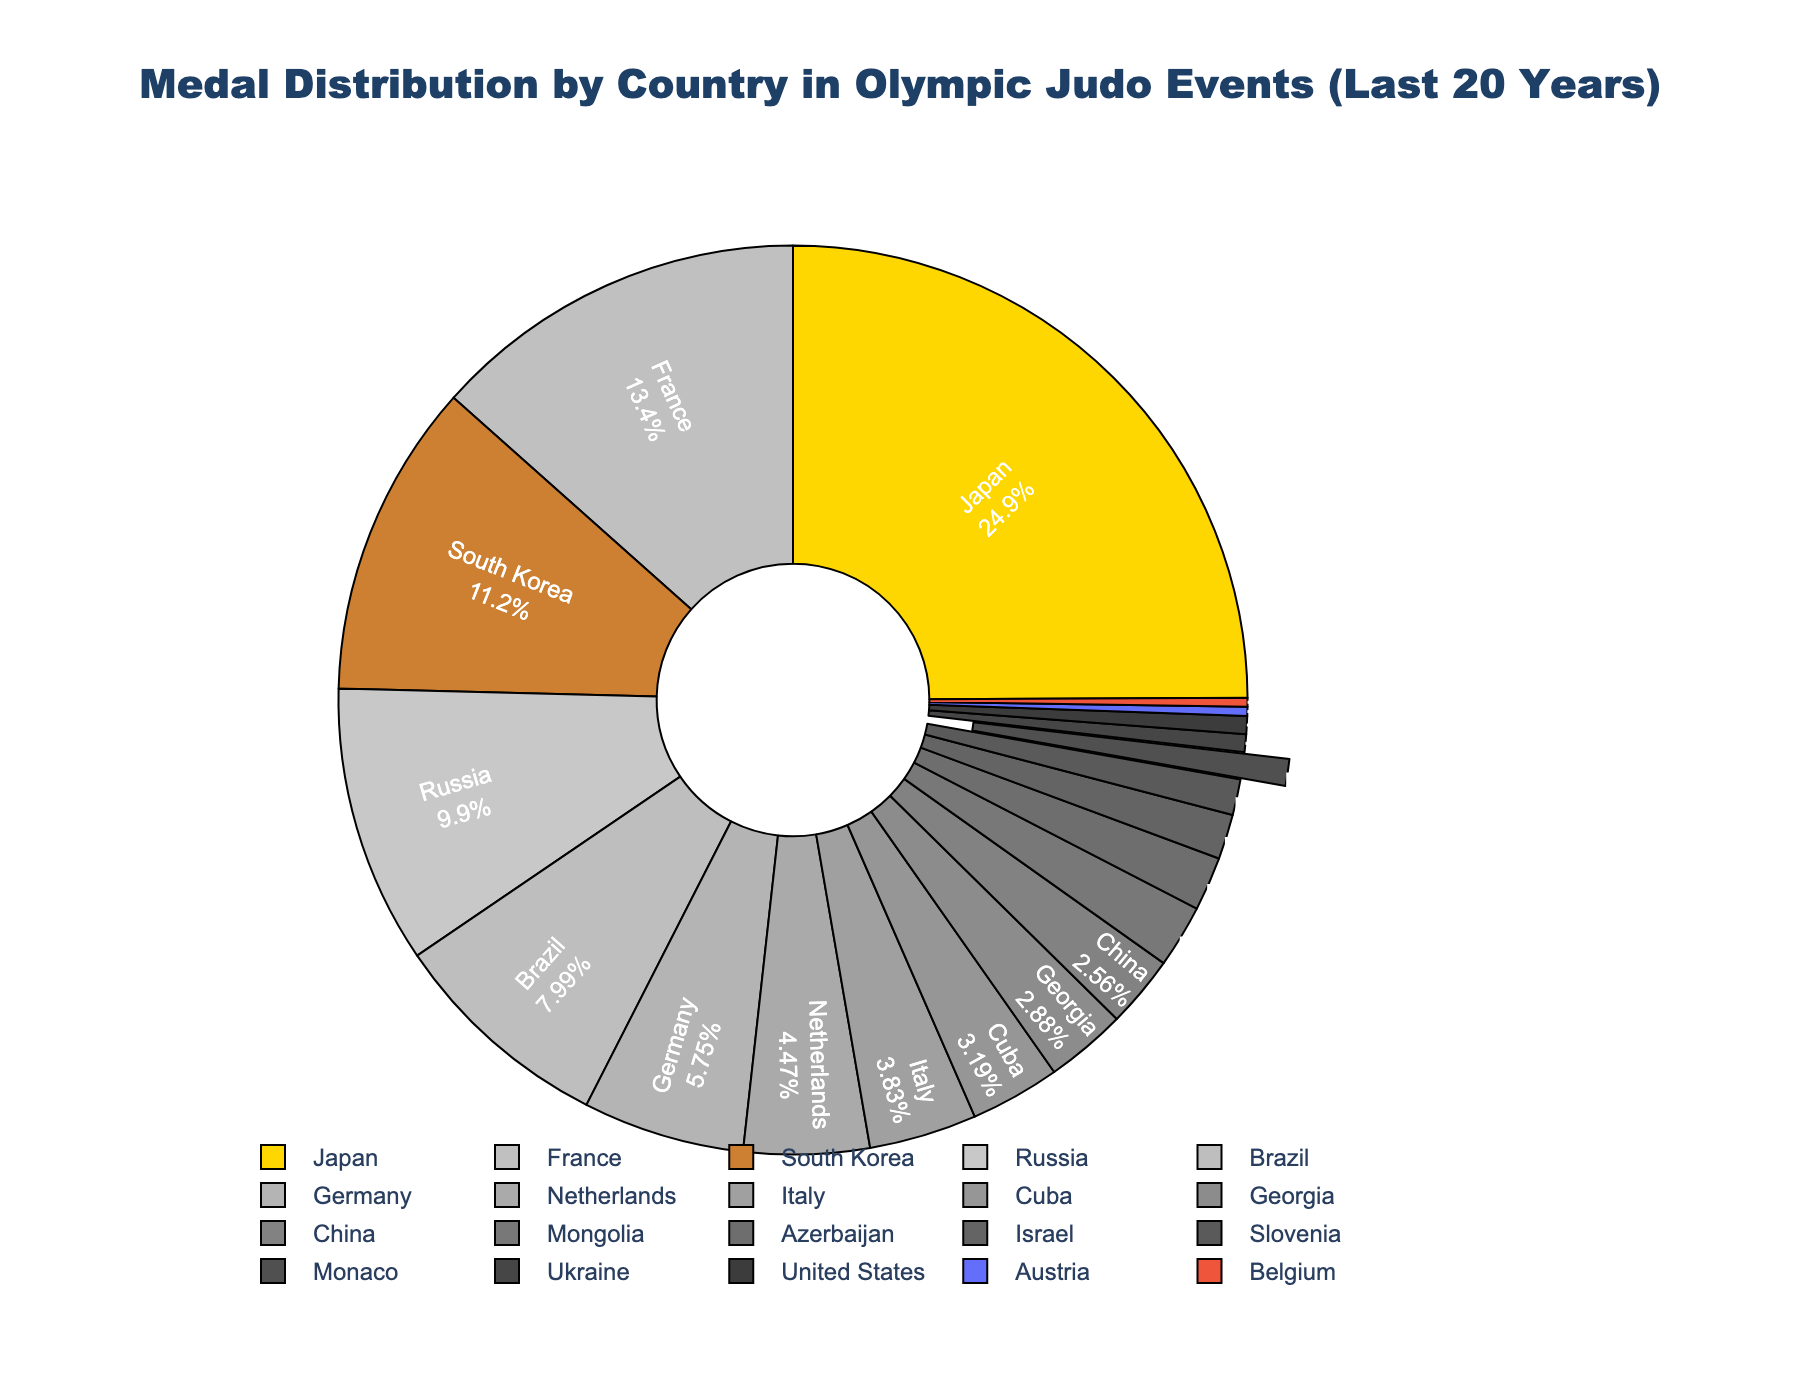Which country has won the most medals in Olympic Judo events over the past 20 years? The pie chart shows Japan has the largest portion, indicating it has won the most medals.
Answer: Japan What percentage of total medals has France won? The chart shows the percentage for each segment. By looking at the segment labeled "France," it shows France has won about 15.38% of the total medals.
Answer: 15.38% How many more medals has Japan won compared to Brazil? Japan has won 78 medals and Brazil 25. The difference is 78 - 25.
Answer: 53 Arrange the following countries by their medal count in descending order: Brazil, South Korea, Russia. The pie chart shows that South Korea has 35 medals, Russia has 31, and Brazil has 25. So the order is South Korea > Russia > Brazil.
Answer: South Korea, Russia, Brazil What is the total number of medals won by Cuba, Georgia, and China combined? Adding the medal counts for Cuba (10), Georgia (9), and China (8): 10 + 9 + 8 = 27.
Answer: 27 What visual distinction is used to highlight Monaco's position in the pie chart? The slice representing Monaco is slightly pulled out from the pie chart to emphasize it.
Answer: The slice is pulled out Which four countries have the smallest medal counts and how many medals have they won in total? The pie chart shows that Austria, Belgium, Ukraine, and the United States have the smallest counts: Austria (1), Belgium (1), Ukraine (2), United States (2). Adding these gives 1 + 1 + 2 + 2 = 6.
Answer: Austria, Belgium, Ukraine, United States; 6 What visual element indicates the relative size of Japan's medal count compared to other countries? The slice corresponding to Japan is the largest in the pie chart, indicating its high medal count.
Answer: Largest slice Among the countries shown, which have won exactly the same number of medals? The pie chart shows Belgium and Austria both won 1 medal each, and Ukraine and the United States both won 2 medals each.
Answer: Belgium and Austria; Ukraine and the United States What is the combined percentage of medals won by Japan and France? Adding the percentages for Japan (~28.42%) and France (~15.38%) from the pie chart, the combined percentage is ~43.8%.
Answer: 43.8% 